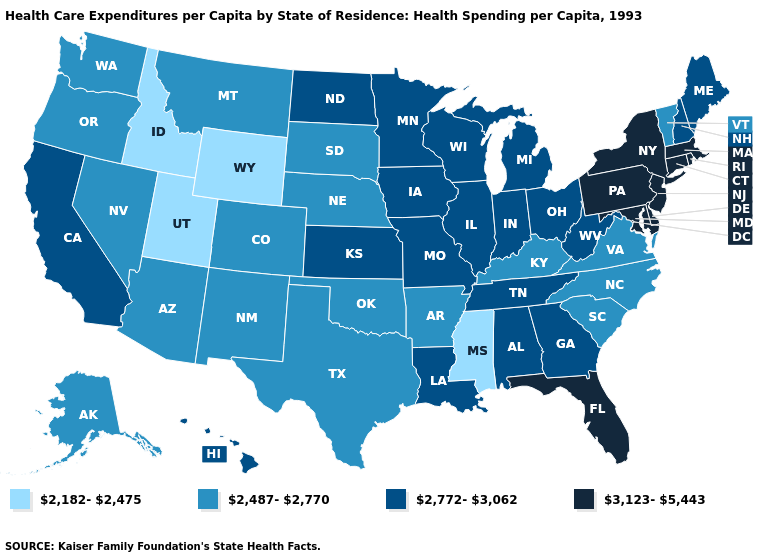Is the legend a continuous bar?
Answer briefly. No. Which states have the lowest value in the USA?
Concise answer only. Idaho, Mississippi, Utah, Wyoming. Which states hav the highest value in the Northeast?
Short answer required. Connecticut, Massachusetts, New Jersey, New York, Pennsylvania, Rhode Island. Does the map have missing data?
Give a very brief answer. No. Among the states that border Colorado , which have the lowest value?
Give a very brief answer. Utah, Wyoming. Does the map have missing data?
Be succinct. No. Among the states that border Indiana , which have the highest value?
Concise answer only. Illinois, Michigan, Ohio. Name the states that have a value in the range 2,182-2,475?
Be succinct. Idaho, Mississippi, Utah, Wyoming. Name the states that have a value in the range 2,182-2,475?
Quick response, please. Idaho, Mississippi, Utah, Wyoming. Does Georgia have the same value as California?
Concise answer only. Yes. What is the lowest value in states that border Tennessee?
Concise answer only. 2,182-2,475. Name the states that have a value in the range 2,772-3,062?
Write a very short answer. Alabama, California, Georgia, Hawaii, Illinois, Indiana, Iowa, Kansas, Louisiana, Maine, Michigan, Minnesota, Missouri, New Hampshire, North Dakota, Ohio, Tennessee, West Virginia, Wisconsin. Name the states that have a value in the range 2,182-2,475?
Quick response, please. Idaho, Mississippi, Utah, Wyoming. What is the highest value in states that border Delaware?
Write a very short answer. 3,123-5,443. What is the lowest value in the West?
Quick response, please. 2,182-2,475. 